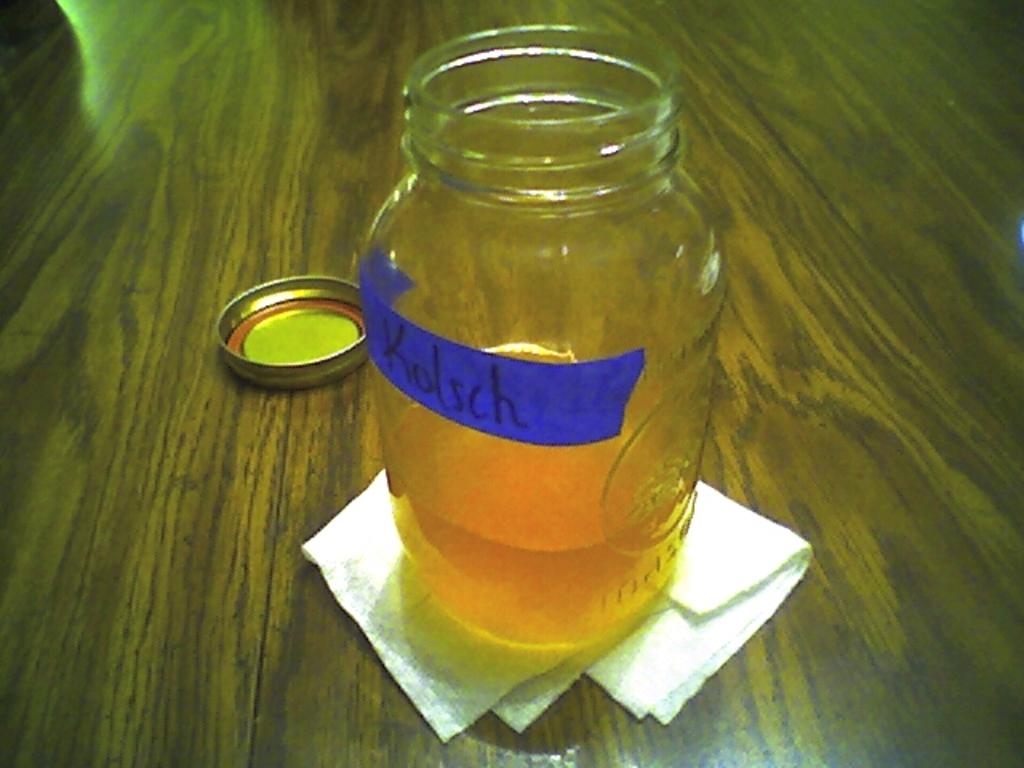<image>
Write a terse but informative summary of the picture. A mason jar labeled Kolsch is open on a wooden table. 